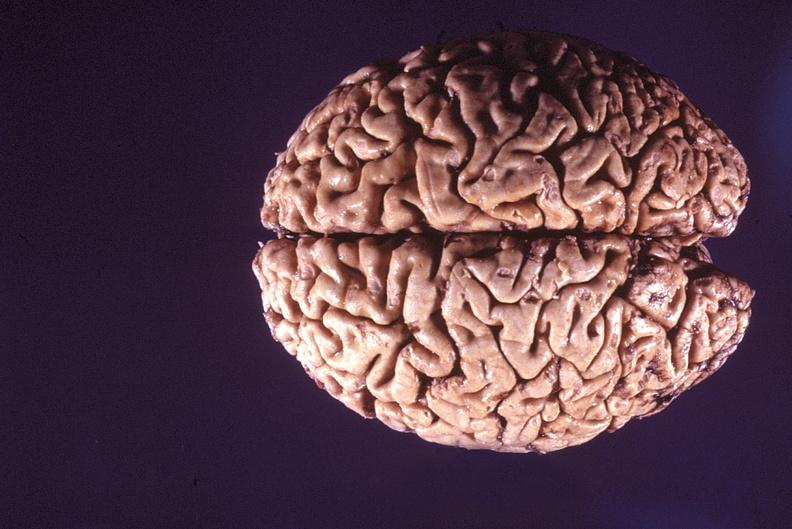does this image show normal brain?
Answer the question using a single word or phrase. Yes 